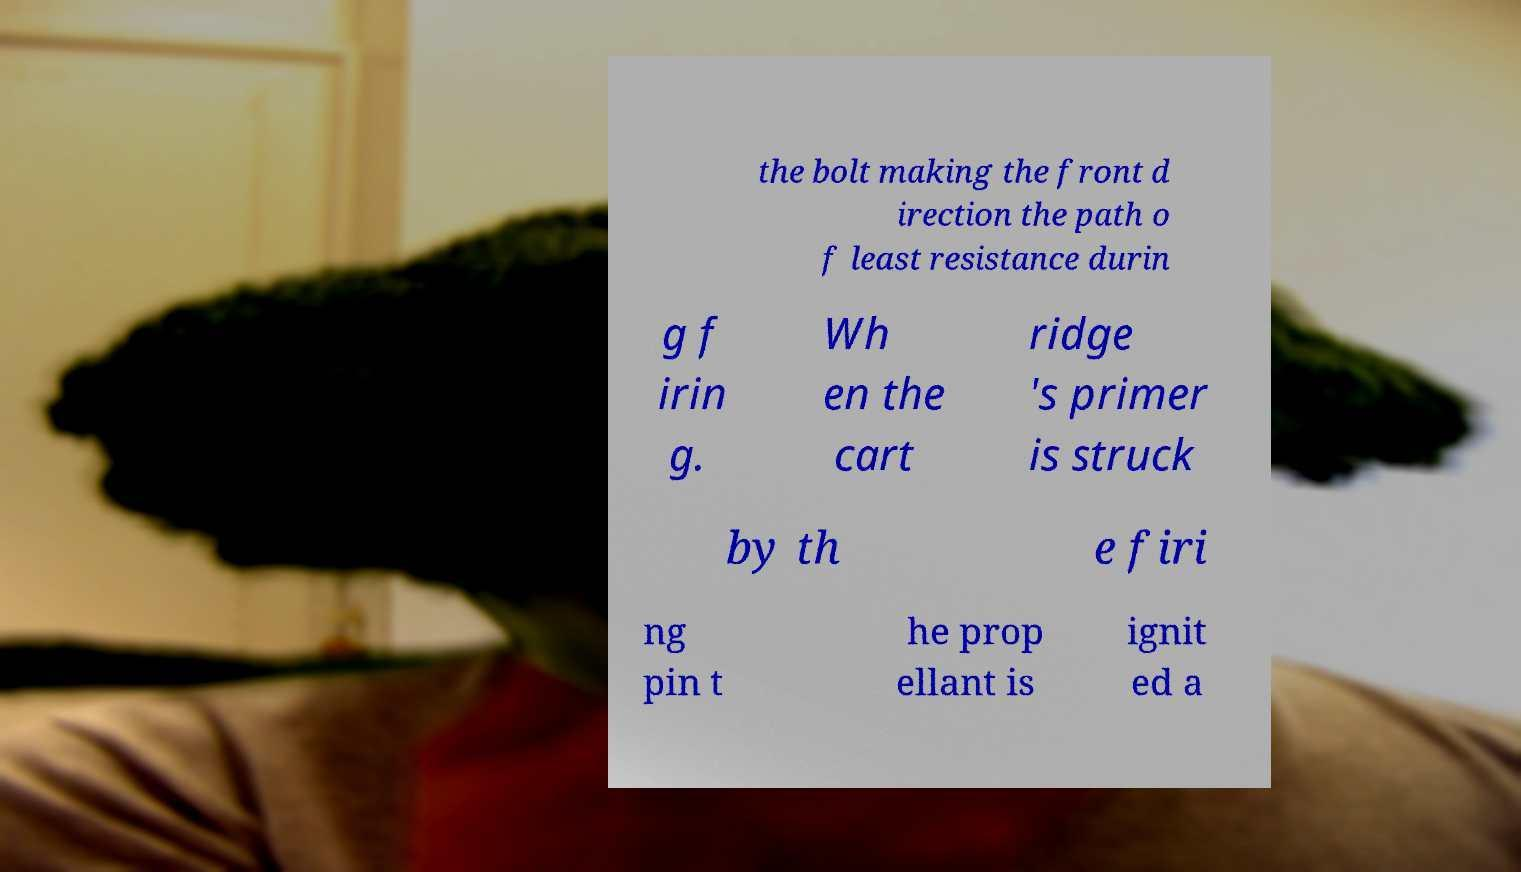Please identify and transcribe the text found in this image. the bolt making the front d irection the path o f least resistance durin g f irin g. Wh en the cart ridge 's primer is struck by th e firi ng pin t he prop ellant is ignit ed a 